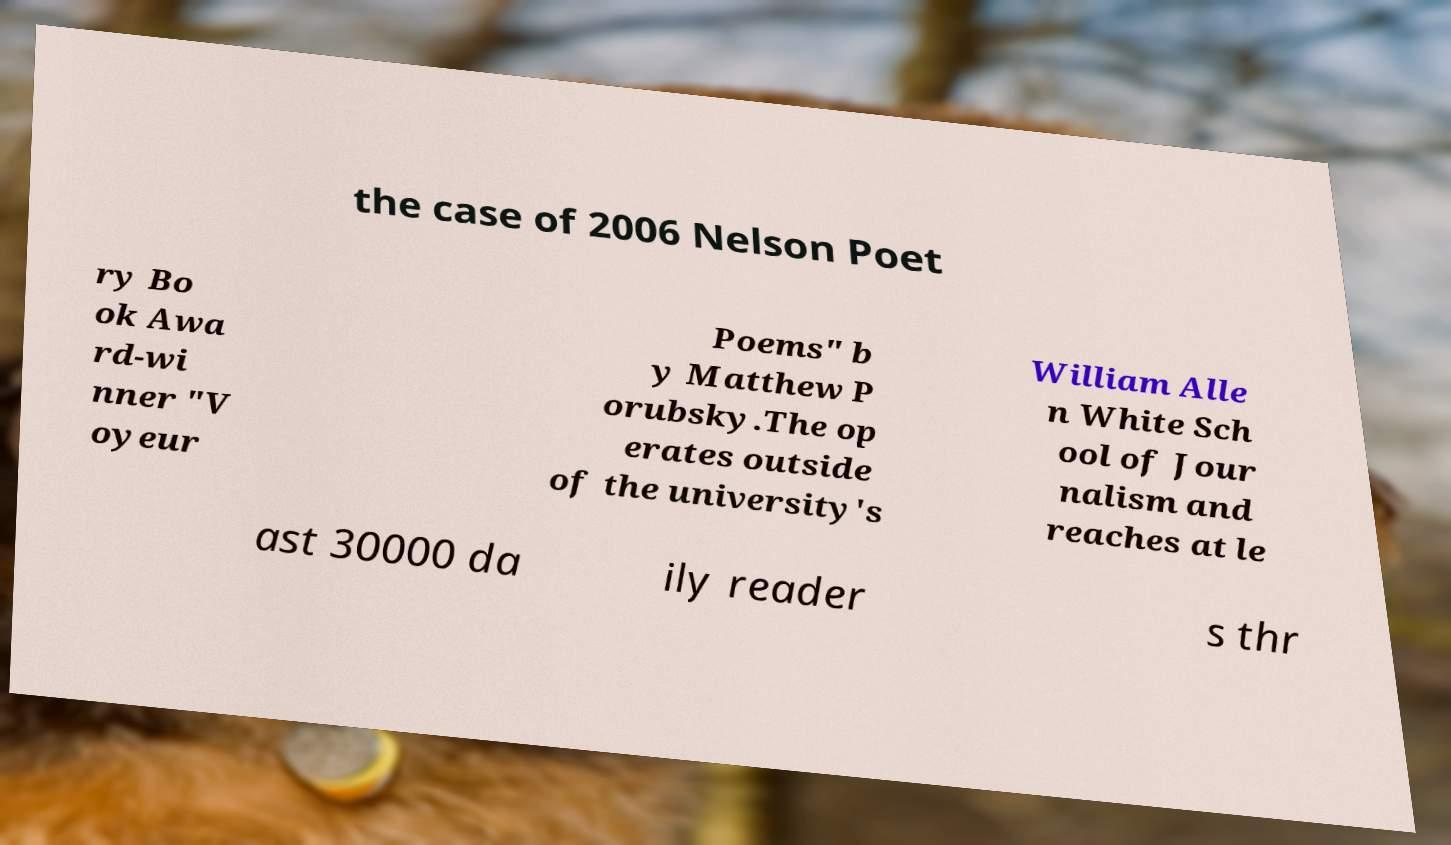I need the written content from this picture converted into text. Can you do that? the case of 2006 Nelson Poet ry Bo ok Awa rd-wi nner "V oyeur Poems" b y Matthew P orubsky.The op erates outside of the university's William Alle n White Sch ool of Jour nalism and reaches at le ast 30000 da ily reader s thr 